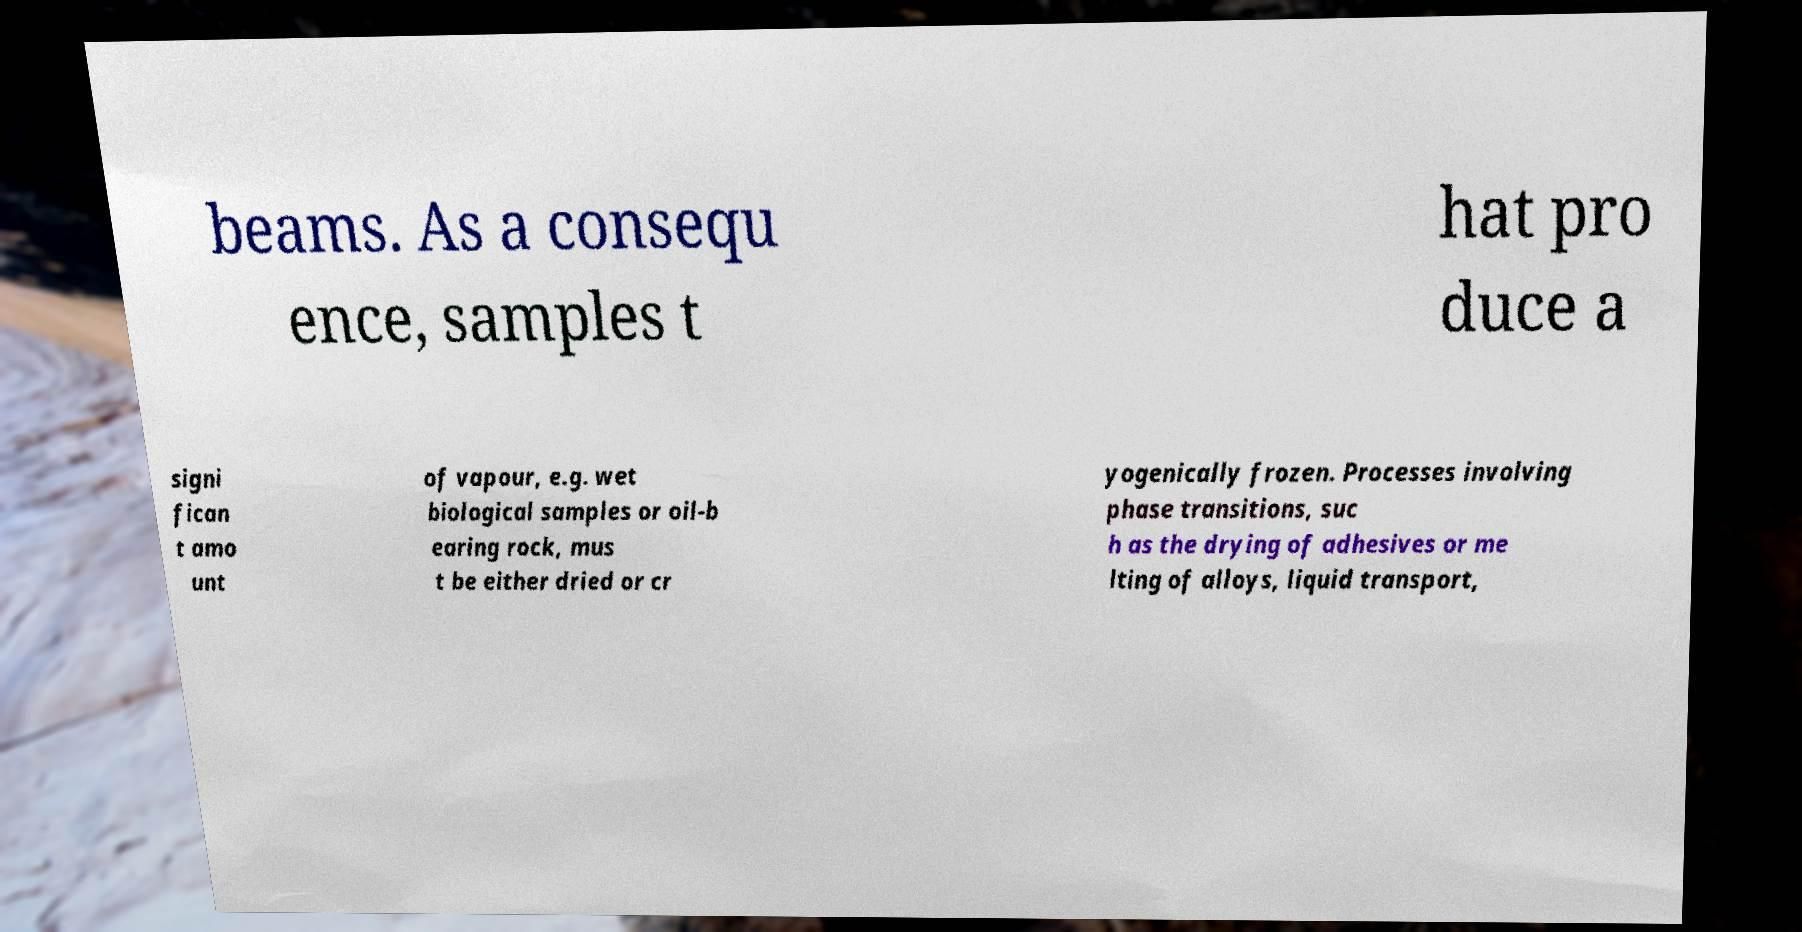Can you accurately transcribe the text from the provided image for me? beams. As a consequ ence, samples t hat pro duce a signi fican t amo unt of vapour, e.g. wet biological samples or oil-b earing rock, mus t be either dried or cr yogenically frozen. Processes involving phase transitions, suc h as the drying of adhesives or me lting of alloys, liquid transport, 